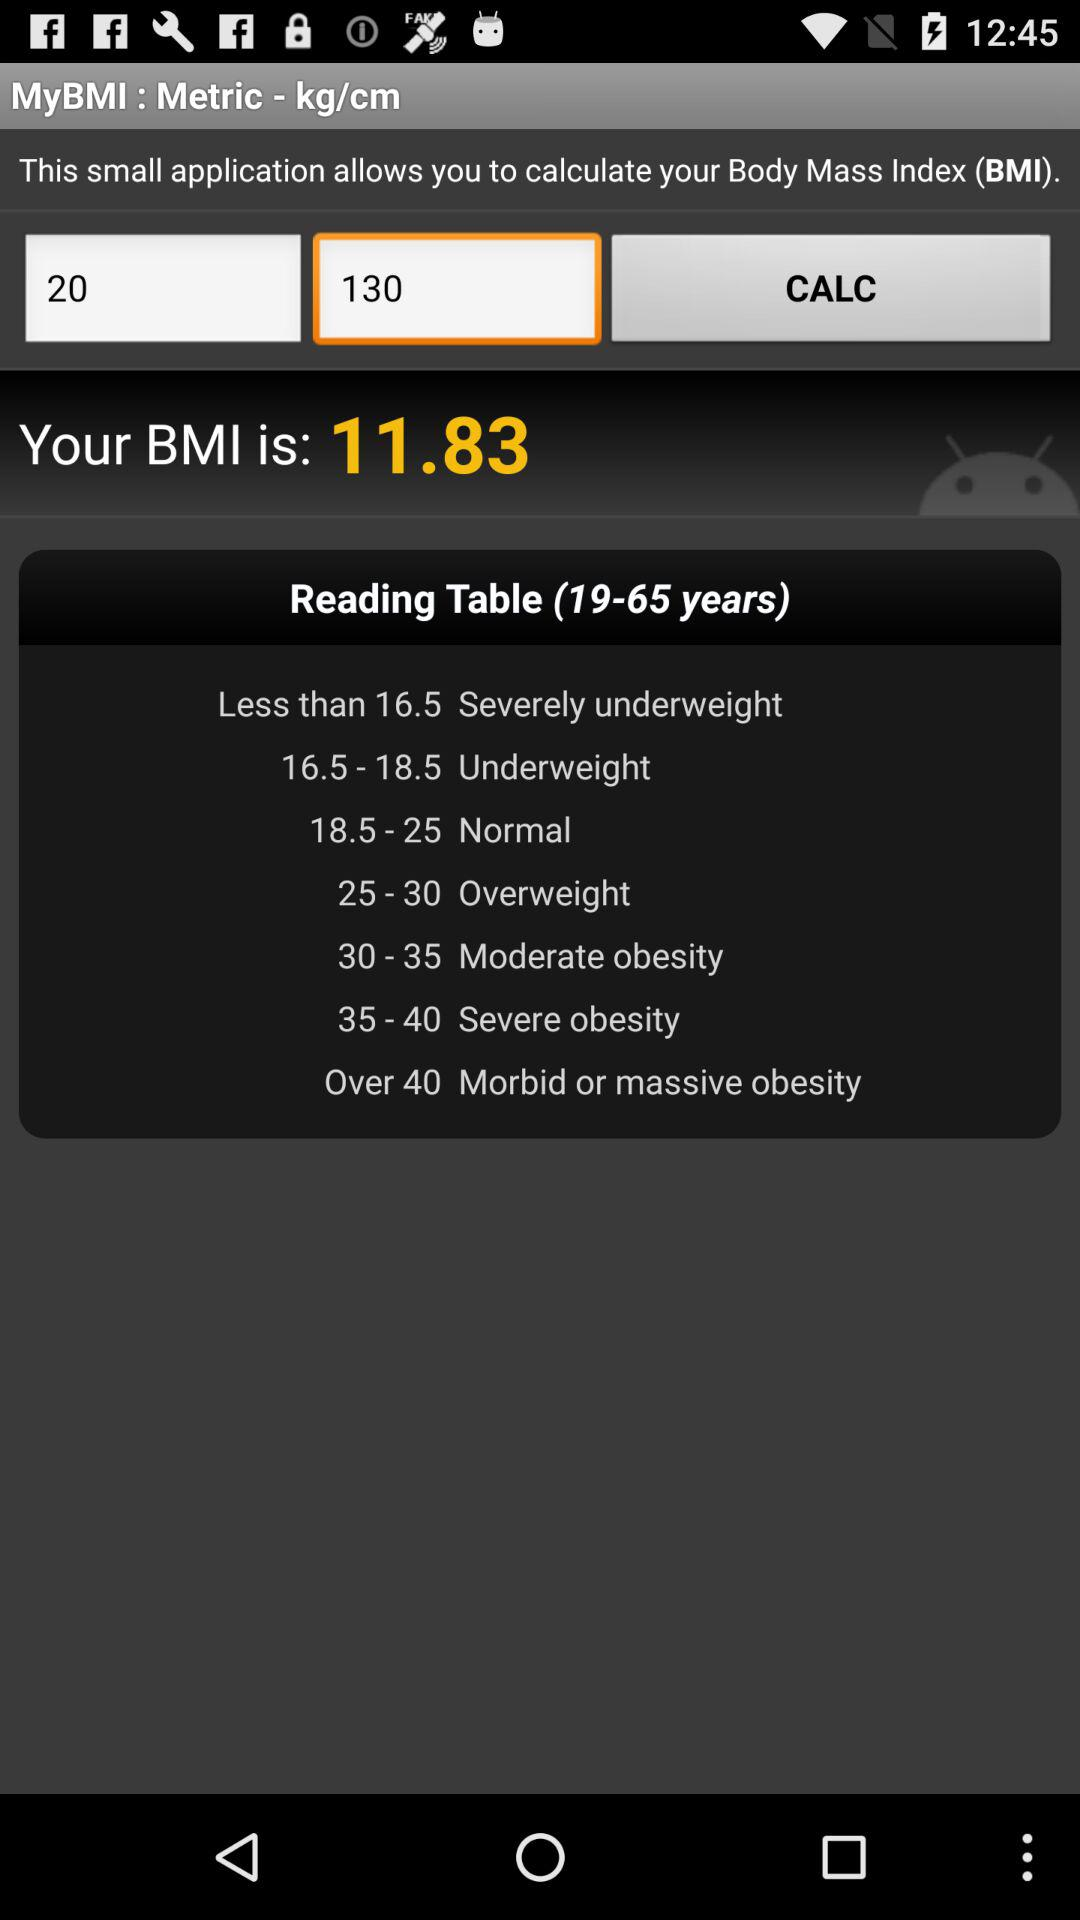What is the year range of the "Reading Table"? The year range is from 19 to 65. 